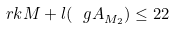Convert formula to latex. <formula><loc_0><loc_0><loc_500><loc_500>\ r k M + l ( { \ g A } _ { M _ { 2 } } ) \leq 2 2</formula> 